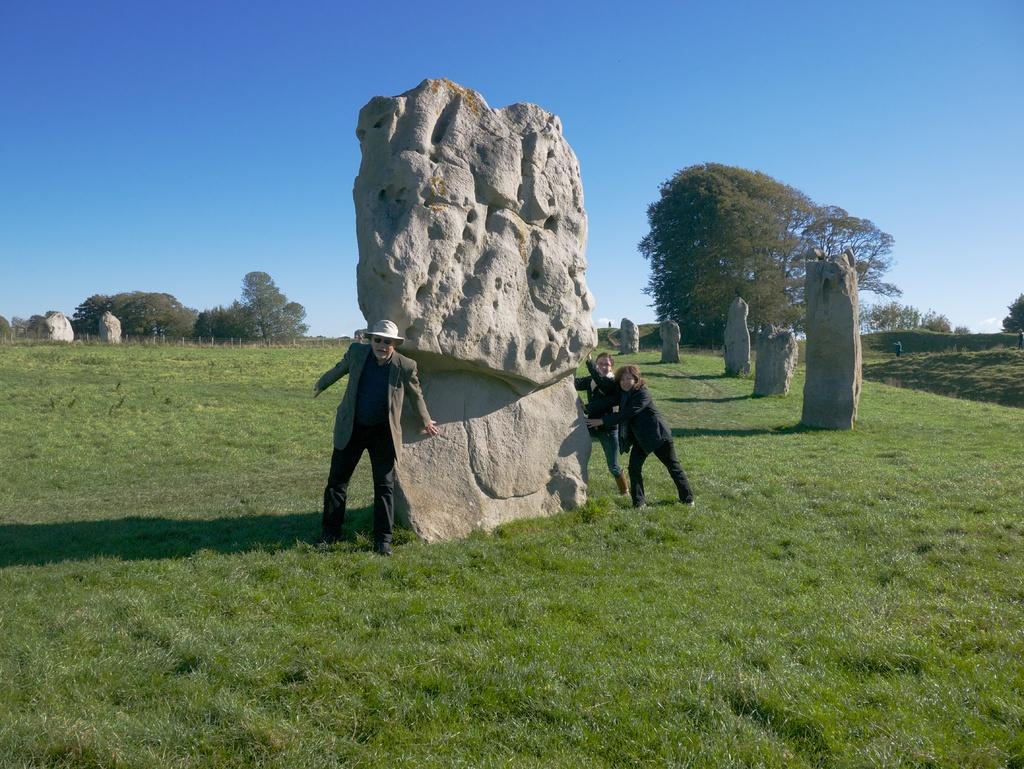Can you describe this image briefly? This is the picture of a place where we have some rocks and some people on the grass floor and around there are some trees. 